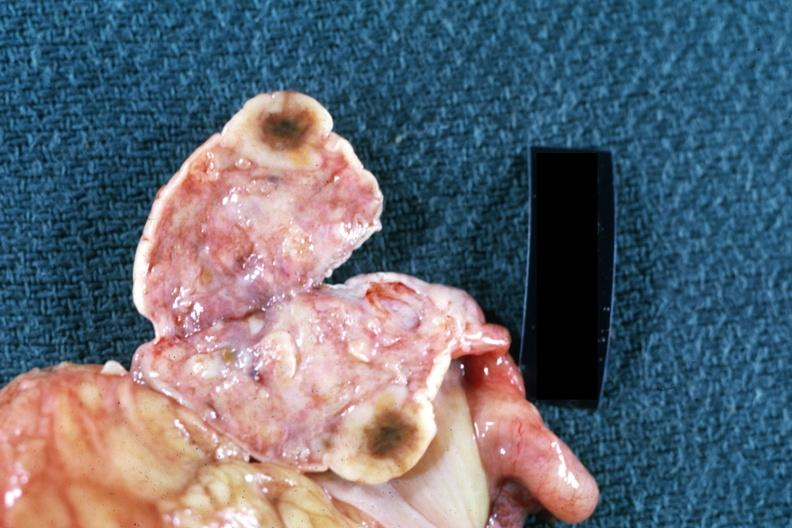s metastatic carcinoma present?
Answer the question using a single word or phrase. Yes 